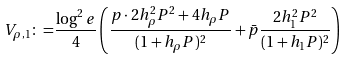<formula> <loc_0><loc_0><loc_500><loc_500>V _ { \rho , 1 } \colon = & \frac { \log ^ { 2 } e } { 4 } \left ( \frac { p \cdot 2 h _ { \rho } ^ { 2 } P ^ { 2 } + 4 h _ { \rho } P } { ( 1 + h _ { \rho } P ) ^ { 2 } } + \bar { p } \frac { 2 h _ { 1 } ^ { 2 } P ^ { 2 } } { ( 1 + h _ { 1 } P ) ^ { 2 } } \right )</formula> 